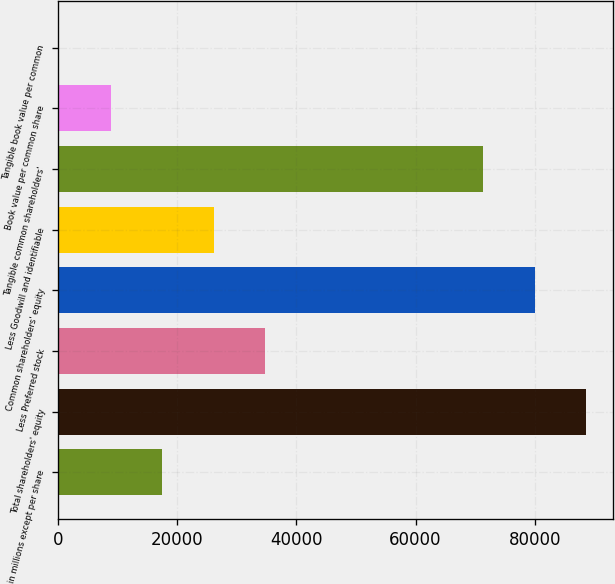<chart> <loc_0><loc_0><loc_500><loc_500><bar_chart><fcel>in millions except per share<fcel>Total shareholders' equity<fcel>Less Preferred stock<fcel>Common shareholders' equity<fcel>Less Goodwill and identifiable<fcel>Tangible common shareholders'<fcel>Book value per common share<fcel>Tangible book value per common<nl><fcel>17474.9<fcel>88693.3<fcel>34788.2<fcel>80036.6<fcel>26131.6<fcel>71380<fcel>8818.28<fcel>161.64<nl></chart> 